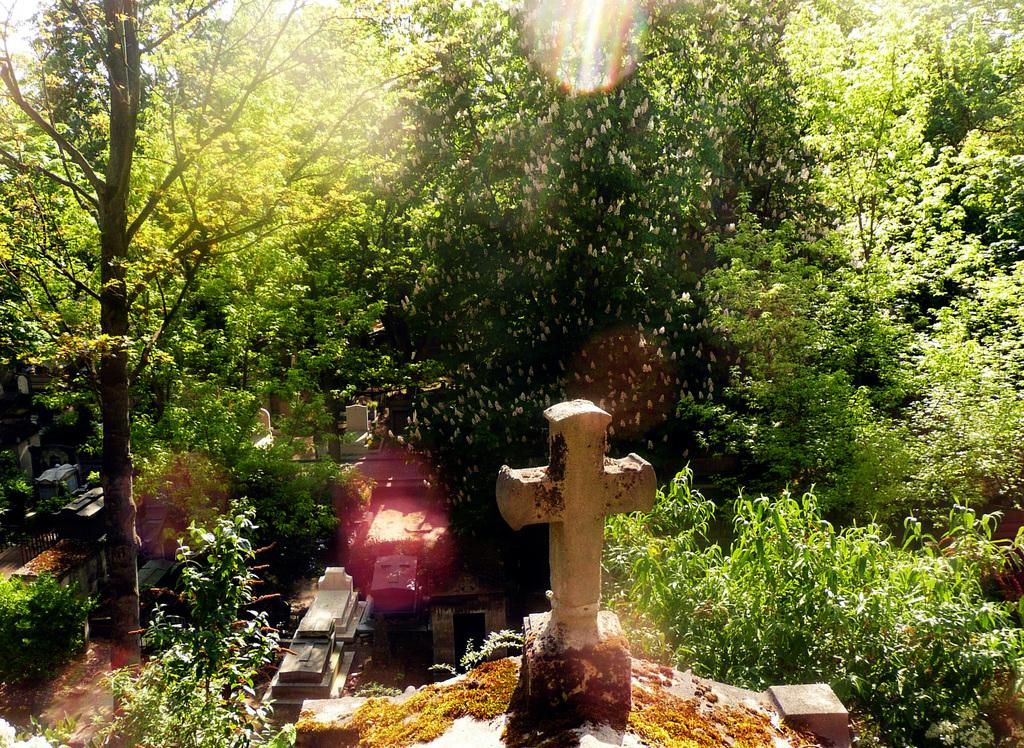What type of location is depicted in the image? There is a graveyard in the image. What natural elements can be seen in the image? There are trees in the image. What religious symbol is present in the image? There is a cross in the image. How does the sheet help to stop the car in the image? There is no car or sheet present in the image; it depicts a graveyard with trees and a cross. 